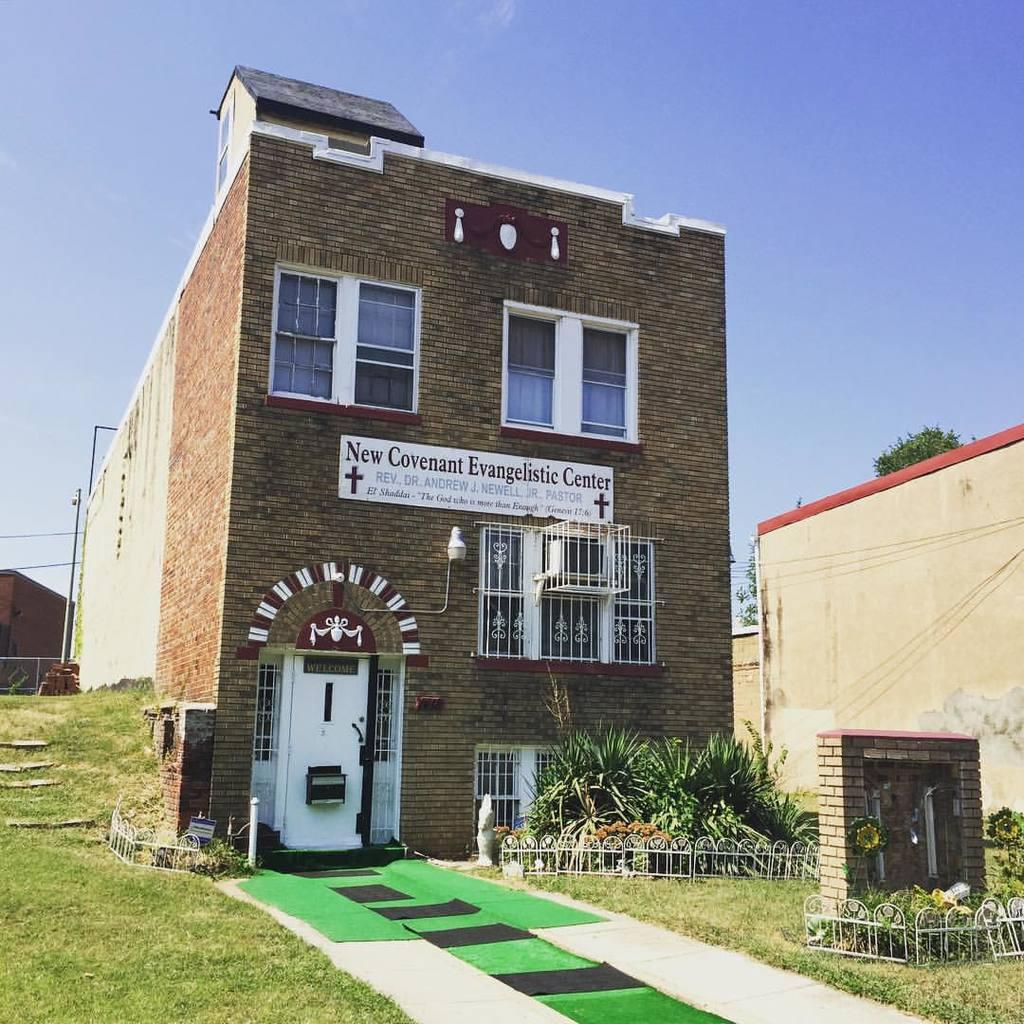What type of structures can be seen in the image? There are houses in the image. What features do the houses have? The houses have windows and doors. Can you describe any additional elements in the image? There is railing, plants, grass, fencing, and a board with text and symbols in the image. What is visible in the background of the image? The sky is visible in the image. How many insects can be seen playing with balls on the roof of the houses in the image? There are no insects or balls present in the image, and therefore no such activity can be observed. 